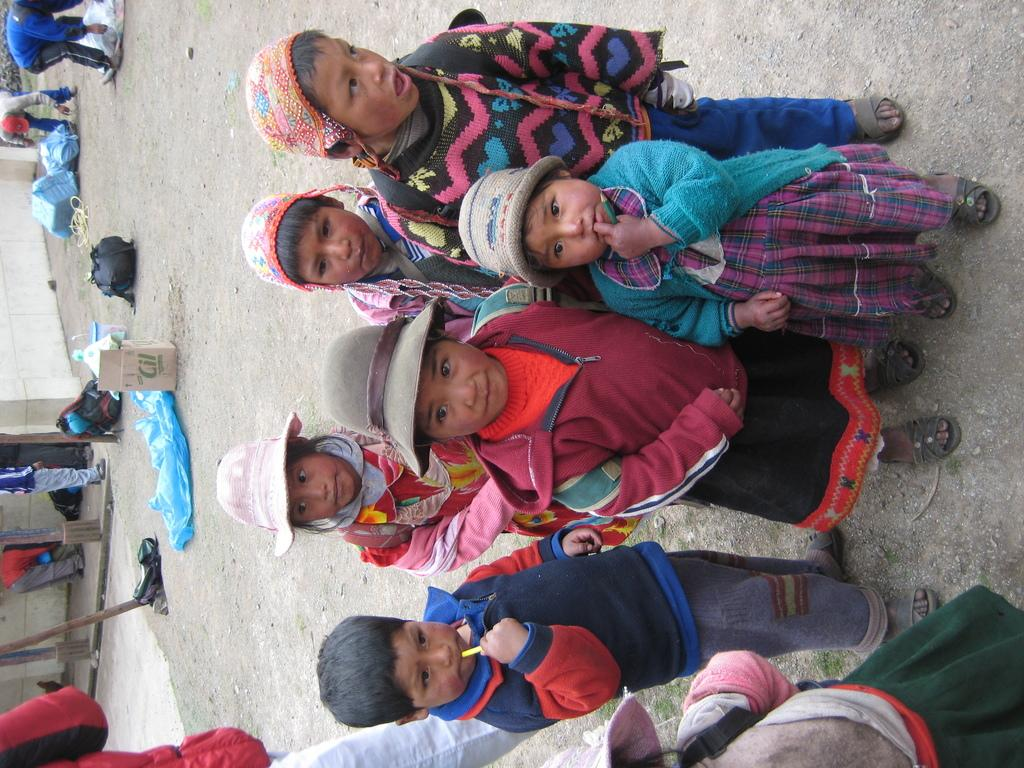How many children are present in the image? There are six children in the image. What are the children wearing? The children are wearing sweaters of different colors. Are any of the children wearing additional accessories? Yes, some children are wearing hats. What can be seen in the background of the image? In the background of the image, there are objects on the ground. How many quarters can be seen on the ground in the image? There are no quarters visible on the ground in the image. What type of grain is present in the image? There is no grain present in the image. 